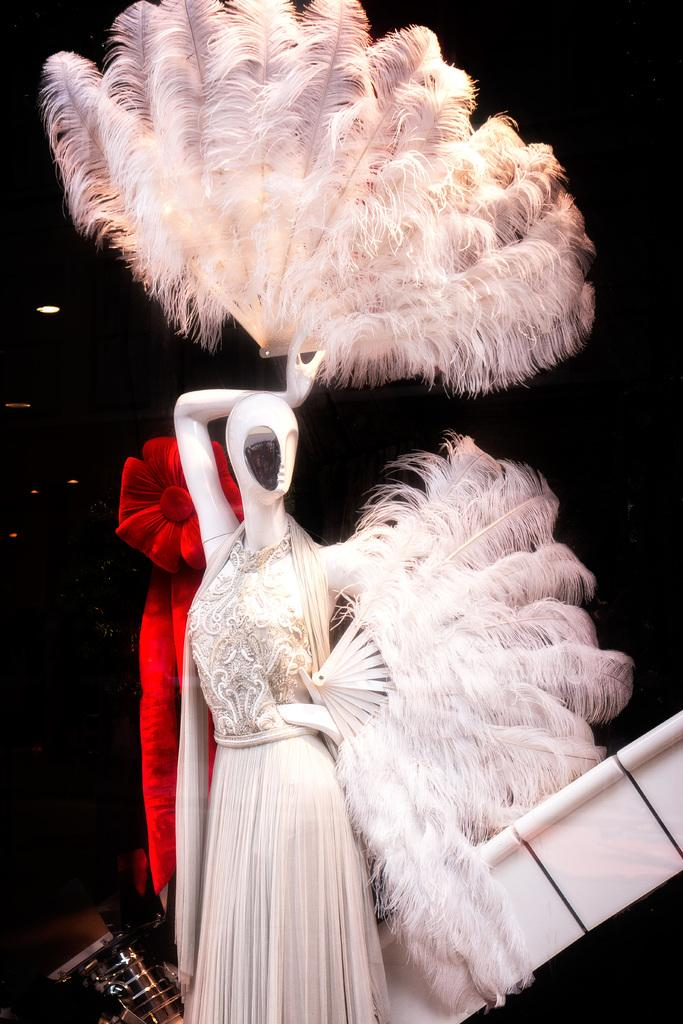What type of clothing is featured in the image? There is a gown in the image. What object is the gown placed on in the image? There is a mannequin in the image. What type of alley can be seen in the background of the image? There is no alley present in the image. What type of achievement is the mannequin celebrating in the image? The image does not depict any achievements or celebrations. Can you tell me how many babies are visible in the image? There are no babies present in the image. 